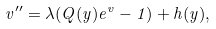Convert formula to latex. <formula><loc_0><loc_0><loc_500><loc_500>v ^ { \prime \prime } = \lambda ( Q ( y ) { e } ^ { v } - 1 ) + h ( y ) ,</formula> 